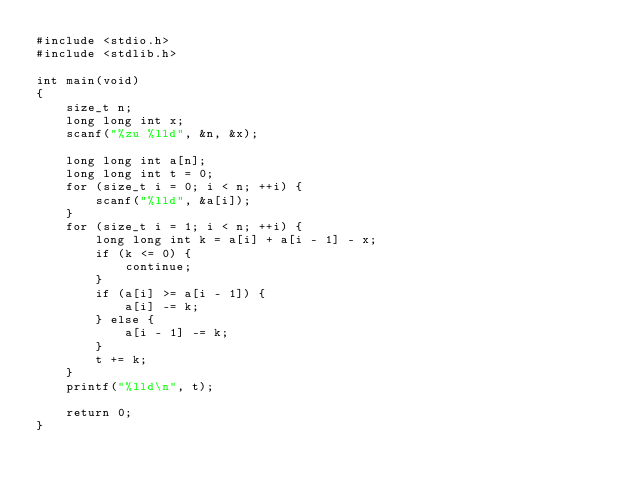Convert code to text. <code><loc_0><loc_0><loc_500><loc_500><_C_>#include <stdio.h>
#include <stdlib.h>

int main(void)
{
    size_t n;
    long long int x;
    scanf("%zu %lld", &n, &x);

    long long int a[n];
    long long int t = 0;
    for (size_t i = 0; i < n; ++i) {
        scanf("%lld", &a[i]);
    }
    for (size_t i = 1; i < n; ++i) {
        long long int k = a[i] + a[i - 1] - x;
        if (k <= 0) {
            continue;
        }
        if (a[i] >= a[i - 1]) {
            a[i] -= k;
        } else {
            a[i - 1] -= k;
        }
        t += k;
    }
    printf("%lld\n", t);

    return 0;
}
</code> 